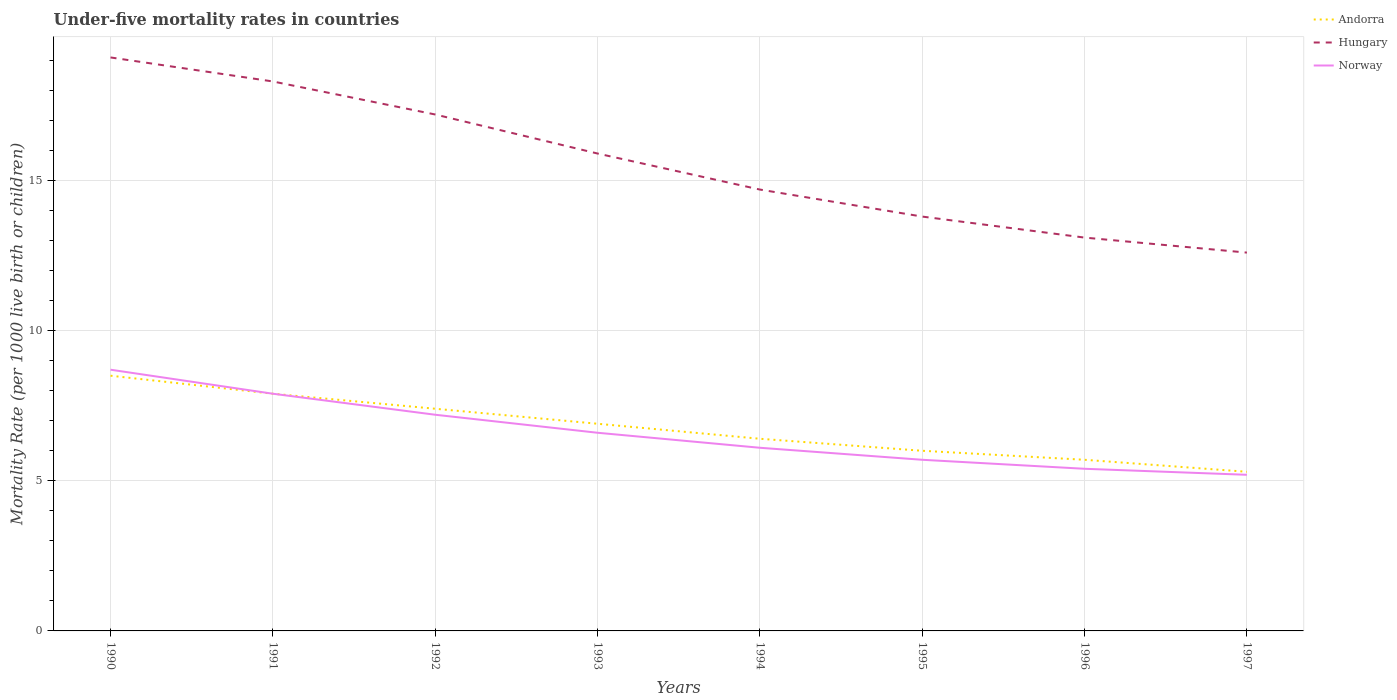Across all years, what is the maximum under-five mortality rate in Hungary?
Provide a succinct answer. 12.6. In which year was the under-five mortality rate in Norway maximum?
Keep it short and to the point. 1997. What is the total under-five mortality rate in Andorra in the graph?
Make the answer very short. 0.4. What is the difference between the highest and the second highest under-five mortality rate in Hungary?
Your answer should be compact. 6.5. How many lines are there?
Give a very brief answer. 3. How many years are there in the graph?
Give a very brief answer. 8. What is the difference between two consecutive major ticks on the Y-axis?
Keep it short and to the point. 5. Are the values on the major ticks of Y-axis written in scientific E-notation?
Your answer should be very brief. No. How many legend labels are there?
Provide a short and direct response. 3. How are the legend labels stacked?
Provide a short and direct response. Vertical. What is the title of the graph?
Ensure brevity in your answer.  Under-five mortality rates in countries. What is the label or title of the X-axis?
Provide a succinct answer. Years. What is the label or title of the Y-axis?
Your response must be concise. Mortality Rate (per 1000 live birth or children). What is the Mortality Rate (per 1000 live birth or children) in Norway in 1992?
Ensure brevity in your answer.  7.2. What is the Mortality Rate (per 1000 live birth or children) in Hungary in 1994?
Keep it short and to the point. 14.7. What is the Mortality Rate (per 1000 live birth or children) of Norway in 1994?
Keep it short and to the point. 6.1. What is the Mortality Rate (per 1000 live birth or children) in Hungary in 1995?
Make the answer very short. 13.8. What is the Mortality Rate (per 1000 live birth or children) in Norway in 1995?
Give a very brief answer. 5.7. What is the Mortality Rate (per 1000 live birth or children) in Andorra in 1996?
Your response must be concise. 5.7. What is the Mortality Rate (per 1000 live birth or children) of Hungary in 1996?
Keep it short and to the point. 13.1. Across all years, what is the minimum Mortality Rate (per 1000 live birth or children) of Andorra?
Provide a succinct answer. 5.3. Across all years, what is the minimum Mortality Rate (per 1000 live birth or children) of Hungary?
Keep it short and to the point. 12.6. Across all years, what is the minimum Mortality Rate (per 1000 live birth or children) of Norway?
Your answer should be very brief. 5.2. What is the total Mortality Rate (per 1000 live birth or children) of Andorra in the graph?
Your answer should be very brief. 54.1. What is the total Mortality Rate (per 1000 live birth or children) of Hungary in the graph?
Give a very brief answer. 124.7. What is the total Mortality Rate (per 1000 live birth or children) of Norway in the graph?
Offer a terse response. 52.8. What is the difference between the Mortality Rate (per 1000 live birth or children) in Andorra in 1990 and that in 1991?
Make the answer very short. 0.6. What is the difference between the Mortality Rate (per 1000 live birth or children) of Andorra in 1990 and that in 1992?
Ensure brevity in your answer.  1.1. What is the difference between the Mortality Rate (per 1000 live birth or children) of Hungary in 1990 and that in 1992?
Your answer should be very brief. 1.9. What is the difference between the Mortality Rate (per 1000 live birth or children) of Andorra in 1990 and that in 1993?
Make the answer very short. 1.6. What is the difference between the Mortality Rate (per 1000 live birth or children) in Hungary in 1990 and that in 1993?
Your answer should be very brief. 3.2. What is the difference between the Mortality Rate (per 1000 live birth or children) in Hungary in 1990 and that in 1994?
Your response must be concise. 4.4. What is the difference between the Mortality Rate (per 1000 live birth or children) in Norway in 1990 and that in 1994?
Make the answer very short. 2.6. What is the difference between the Mortality Rate (per 1000 live birth or children) in Hungary in 1990 and that in 1995?
Keep it short and to the point. 5.3. What is the difference between the Mortality Rate (per 1000 live birth or children) in Norway in 1990 and that in 1995?
Provide a succinct answer. 3. What is the difference between the Mortality Rate (per 1000 live birth or children) in Hungary in 1990 and that in 1996?
Keep it short and to the point. 6. What is the difference between the Mortality Rate (per 1000 live birth or children) in Norway in 1990 and that in 1996?
Offer a very short reply. 3.3. What is the difference between the Mortality Rate (per 1000 live birth or children) in Andorra in 1990 and that in 1997?
Provide a succinct answer. 3.2. What is the difference between the Mortality Rate (per 1000 live birth or children) of Norway in 1990 and that in 1997?
Provide a succinct answer. 3.5. What is the difference between the Mortality Rate (per 1000 live birth or children) of Andorra in 1991 and that in 1992?
Your answer should be very brief. 0.5. What is the difference between the Mortality Rate (per 1000 live birth or children) in Hungary in 1991 and that in 1992?
Provide a short and direct response. 1.1. What is the difference between the Mortality Rate (per 1000 live birth or children) of Andorra in 1991 and that in 1993?
Give a very brief answer. 1. What is the difference between the Mortality Rate (per 1000 live birth or children) of Andorra in 1991 and that in 1994?
Your answer should be very brief. 1.5. What is the difference between the Mortality Rate (per 1000 live birth or children) of Andorra in 1991 and that in 1997?
Provide a short and direct response. 2.6. What is the difference between the Mortality Rate (per 1000 live birth or children) of Hungary in 1991 and that in 1997?
Your response must be concise. 5.7. What is the difference between the Mortality Rate (per 1000 live birth or children) of Norway in 1991 and that in 1997?
Make the answer very short. 2.7. What is the difference between the Mortality Rate (per 1000 live birth or children) in Andorra in 1992 and that in 1993?
Offer a terse response. 0.5. What is the difference between the Mortality Rate (per 1000 live birth or children) in Hungary in 1992 and that in 1993?
Your answer should be compact. 1.3. What is the difference between the Mortality Rate (per 1000 live birth or children) in Norway in 1992 and that in 1993?
Provide a short and direct response. 0.6. What is the difference between the Mortality Rate (per 1000 live birth or children) in Hungary in 1992 and that in 1995?
Your answer should be very brief. 3.4. What is the difference between the Mortality Rate (per 1000 live birth or children) in Norway in 1992 and that in 1996?
Make the answer very short. 1.8. What is the difference between the Mortality Rate (per 1000 live birth or children) of Hungary in 1992 and that in 1997?
Provide a succinct answer. 4.6. What is the difference between the Mortality Rate (per 1000 live birth or children) in Norway in 1993 and that in 1994?
Give a very brief answer. 0.5. What is the difference between the Mortality Rate (per 1000 live birth or children) of Andorra in 1993 and that in 1995?
Give a very brief answer. 0.9. What is the difference between the Mortality Rate (per 1000 live birth or children) of Norway in 1993 and that in 1995?
Provide a short and direct response. 0.9. What is the difference between the Mortality Rate (per 1000 live birth or children) in Andorra in 1993 and that in 1996?
Offer a very short reply. 1.2. What is the difference between the Mortality Rate (per 1000 live birth or children) of Norway in 1993 and that in 1996?
Your answer should be very brief. 1.2. What is the difference between the Mortality Rate (per 1000 live birth or children) of Andorra in 1994 and that in 1995?
Offer a terse response. 0.4. What is the difference between the Mortality Rate (per 1000 live birth or children) in Hungary in 1994 and that in 1995?
Offer a terse response. 0.9. What is the difference between the Mortality Rate (per 1000 live birth or children) in Norway in 1994 and that in 1995?
Your answer should be very brief. 0.4. What is the difference between the Mortality Rate (per 1000 live birth or children) in Andorra in 1994 and that in 1996?
Offer a terse response. 0.7. What is the difference between the Mortality Rate (per 1000 live birth or children) in Hungary in 1994 and that in 1996?
Offer a very short reply. 1.6. What is the difference between the Mortality Rate (per 1000 live birth or children) of Norway in 1994 and that in 1996?
Give a very brief answer. 0.7. What is the difference between the Mortality Rate (per 1000 live birth or children) in Andorra in 1994 and that in 1997?
Ensure brevity in your answer.  1.1. What is the difference between the Mortality Rate (per 1000 live birth or children) in Hungary in 1994 and that in 1997?
Offer a terse response. 2.1. What is the difference between the Mortality Rate (per 1000 live birth or children) of Norway in 1994 and that in 1997?
Your answer should be compact. 0.9. What is the difference between the Mortality Rate (per 1000 live birth or children) in Andorra in 1995 and that in 1996?
Offer a terse response. 0.3. What is the difference between the Mortality Rate (per 1000 live birth or children) in Hungary in 1995 and that in 1996?
Make the answer very short. 0.7. What is the difference between the Mortality Rate (per 1000 live birth or children) of Norway in 1995 and that in 1996?
Offer a terse response. 0.3. What is the difference between the Mortality Rate (per 1000 live birth or children) in Andorra in 1995 and that in 1997?
Ensure brevity in your answer.  0.7. What is the difference between the Mortality Rate (per 1000 live birth or children) of Hungary in 1995 and that in 1997?
Your response must be concise. 1.2. What is the difference between the Mortality Rate (per 1000 live birth or children) in Hungary in 1996 and that in 1997?
Your answer should be compact. 0.5. What is the difference between the Mortality Rate (per 1000 live birth or children) in Andorra in 1990 and the Mortality Rate (per 1000 live birth or children) in Hungary in 1991?
Your answer should be very brief. -9.8. What is the difference between the Mortality Rate (per 1000 live birth or children) of Andorra in 1990 and the Mortality Rate (per 1000 live birth or children) of Norway in 1991?
Offer a very short reply. 0.6. What is the difference between the Mortality Rate (per 1000 live birth or children) in Hungary in 1990 and the Mortality Rate (per 1000 live birth or children) in Norway in 1991?
Your answer should be very brief. 11.2. What is the difference between the Mortality Rate (per 1000 live birth or children) of Andorra in 1990 and the Mortality Rate (per 1000 live birth or children) of Hungary in 1992?
Keep it short and to the point. -8.7. What is the difference between the Mortality Rate (per 1000 live birth or children) of Andorra in 1990 and the Mortality Rate (per 1000 live birth or children) of Norway in 1992?
Provide a short and direct response. 1.3. What is the difference between the Mortality Rate (per 1000 live birth or children) of Hungary in 1990 and the Mortality Rate (per 1000 live birth or children) of Norway in 1992?
Offer a terse response. 11.9. What is the difference between the Mortality Rate (per 1000 live birth or children) of Hungary in 1990 and the Mortality Rate (per 1000 live birth or children) of Norway in 1993?
Give a very brief answer. 12.5. What is the difference between the Mortality Rate (per 1000 live birth or children) in Andorra in 1990 and the Mortality Rate (per 1000 live birth or children) in Hungary in 1994?
Provide a succinct answer. -6.2. What is the difference between the Mortality Rate (per 1000 live birth or children) of Andorra in 1990 and the Mortality Rate (per 1000 live birth or children) of Norway in 1994?
Provide a short and direct response. 2.4. What is the difference between the Mortality Rate (per 1000 live birth or children) in Hungary in 1990 and the Mortality Rate (per 1000 live birth or children) in Norway in 1994?
Offer a terse response. 13. What is the difference between the Mortality Rate (per 1000 live birth or children) in Andorra in 1990 and the Mortality Rate (per 1000 live birth or children) in Norway in 1995?
Make the answer very short. 2.8. What is the difference between the Mortality Rate (per 1000 live birth or children) of Andorra in 1990 and the Mortality Rate (per 1000 live birth or children) of Hungary in 1996?
Provide a succinct answer. -4.6. What is the difference between the Mortality Rate (per 1000 live birth or children) in Andorra in 1990 and the Mortality Rate (per 1000 live birth or children) in Hungary in 1997?
Your response must be concise. -4.1. What is the difference between the Mortality Rate (per 1000 live birth or children) in Hungary in 1990 and the Mortality Rate (per 1000 live birth or children) in Norway in 1997?
Provide a succinct answer. 13.9. What is the difference between the Mortality Rate (per 1000 live birth or children) of Andorra in 1991 and the Mortality Rate (per 1000 live birth or children) of Hungary in 1992?
Your answer should be very brief. -9.3. What is the difference between the Mortality Rate (per 1000 live birth or children) in Hungary in 1991 and the Mortality Rate (per 1000 live birth or children) in Norway in 1992?
Offer a very short reply. 11.1. What is the difference between the Mortality Rate (per 1000 live birth or children) in Andorra in 1991 and the Mortality Rate (per 1000 live birth or children) in Hungary in 1993?
Make the answer very short. -8. What is the difference between the Mortality Rate (per 1000 live birth or children) of Andorra in 1991 and the Mortality Rate (per 1000 live birth or children) of Hungary in 1994?
Your answer should be compact. -6.8. What is the difference between the Mortality Rate (per 1000 live birth or children) in Andorra in 1991 and the Mortality Rate (per 1000 live birth or children) in Norway in 1994?
Your answer should be very brief. 1.8. What is the difference between the Mortality Rate (per 1000 live birth or children) of Andorra in 1991 and the Mortality Rate (per 1000 live birth or children) of Norway in 1995?
Offer a very short reply. 2.2. What is the difference between the Mortality Rate (per 1000 live birth or children) of Andorra in 1991 and the Mortality Rate (per 1000 live birth or children) of Hungary in 1997?
Make the answer very short. -4.7. What is the difference between the Mortality Rate (per 1000 live birth or children) of Andorra in 1991 and the Mortality Rate (per 1000 live birth or children) of Norway in 1997?
Provide a short and direct response. 2.7. What is the difference between the Mortality Rate (per 1000 live birth or children) in Hungary in 1991 and the Mortality Rate (per 1000 live birth or children) in Norway in 1997?
Offer a very short reply. 13.1. What is the difference between the Mortality Rate (per 1000 live birth or children) of Andorra in 1992 and the Mortality Rate (per 1000 live birth or children) of Hungary in 1993?
Your answer should be compact. -8.5. What is the difference between the Mortality Rate (per 1000 live birth or children) in Andorra in 1992 and the Mortality Rate (per 1000 live birth or children) in Norway in 1993?
Your answer should be compact. 0.8. What is the difference between the Mortality Rate (per 1000 live birth or children) of Andorra in 1992 and the Mortality Rate (per 1000 live birth or children) of Hungary in 1994?
Offer a very short reply. -7.3. What is the difference between the Mortality Rate (per 1000 live birth or children) of Hungary in 1992 and the Mortality Rate (per 1000 live birth or children) of Norway in 1994?
Your answer should be very brief. 11.1. What is the difference between the Mortality Rate (per 1000 live birth or children) in Andorra in 1992 and the Mortality Rate (per 1000 live birth or children) in Hungary in 1995?
Keep it short and to the point. -6.4. What is the difference between the Mortality Rate (per 1000 live birth or children) of Andorra in 1992 and the Mortality Rate (per 1000 live birth or children) of Norway in 1995?
Offer a terse response. 1.7. What is the difference between the Mortality Rate (per 1000 live birth or children) of Hungary in 1992 and the Mortality Rate (per 1000 live birth or children) of Norway in 1995?
Provide a succinct answer. 11.5. What is the difference between the Mortality Rate (per 1000 live birth or children) in Andorra in 1992 and the Mortality Rate (per 1000 live birth or children) in Hungary in 1996?
Provide a succinct answer. -5.7. What is the difference between the Mortality Rate (per 1000 live birth or children) of Andorra in 1992 and the Mortality Rate (per 1000 live birth or children) of Norway in 1996?
Keep it short and to the point. 2. What is the difference between the Mortality Rate (per 1000 live birth or children) of Andorra in 1992 and the Mortality Rate (per 1000 live birth or children) of Hungary in 1997?
Offer a very short reply. -5.2. What is the difference between the Mortality Rate (per 1000 live birth or children) in Andorra in 1992 and the Mortality Rate (per 1000 live birth or children) in Norway in 1997?
Your answer should be compact. 2.2. What is the difference between the Mortality Rate (per 1000 live birth or children) in Hungary in 1992 and the Mortality Rate (per 1000 live birth or children) in Norway in 1997?
Make the answer very short. 12. What is the difference between the Mortality Rate (per 1000 live birth or children) of Andorra in 1993 and the Mortality Rate (per 1000 live birth or children) of Hungary in 1994?
Ensure brevity in your answer.  -7.8. What is the difference between the Mortality Rate (per 1000 live birth or children) in Andorra in 1993 and the Mortality Rate (per 1000 live birth or children) in Norway in 1994?
Keep it short and to the point. 0.8. What is the difference between the Mortality Rate (per 1000 live birth or children) in Andorra in 1993 and the Mortality Rate (per 1000 live birth or children) in Hungary in 1995?
Keep it short and to the point. -6.9. What is the difference between the Mortality Rate (per 1000 live birth or children) of Hungary in 1993 and the Mortality Rate (per 1000 live birth or children) of Norway in 1995?
Your response must be concise. 10.2. What is the difference between the Mortality Rate (per 1000 live birth or children) of Andorra in 1993 and the Mortality Rate (per 1000 live birth or children) of Hungary in 1996?
Ensure brevity in your answer.  -6.2. What is the difference between the Mortality Rate (per 1000 live birth or children) in Andorra in 1993 and the Mortality Rate (per 1000 live birth or children) in Norway in 1996?
Ensure brevity in your answer.  1.5. What is the difference between the Mortality Rate (per 1000 live birth or children) of Andorra in 1993 and the Mortality Rate (per 1000 live birth or children) of Hungary in 1997?
Offer a very short reply. -5.7. What is the difference between the Mortality Rate (per 1000 live birth or children) of Andorra in 1993 and the Mortality Rate (per 1000 live birth or children) of Norway in 1997?
Ensure brevity in your answer.  1.7. What is the difference between the Mortality Rate (per 1000 live birth or children) in Hungary in 1993 and the Mortality Rate (per 1000 live birth or children) in Norway in 1997?
Offer a very short reply. 10.7. What is the difference between the Mortality Rate (per 1000 live birth or children) of Andorra in 1994 and the Mortality Rate (per 1000 live birth or children) of Norway in 1995?
Provide a succinct answer. 0.7. What is the difference between the Mortality Rate (per 1000 live birth or children) of Hungary in 1994 and the Mortality Rate (per 1000 live birth or children) of Norway in 1995?
Your answer should be very brief. 9. What is the difference between the Mortality Rate (per 1000 live birth or children) in Andorra in 1994 and the Mortality Rate (per 1000 live birth or children) in Norway in 1996?
Your response must be concise. 1. What is the difference between the Mortality Rate (per 1000 live birth or children) of Hungary in 1994 and the Mortality Rate (per 1000 live birth or children) of Norway in 1996?
Provide a succinct answer. 9.3. What is the difference between the Mortality Rate (per 1000 live birth or children) in Andorra in 1994 and the Mortality Rate (per 1000 live birth or children) in Norway in 1997?
Give a very brief answer. 1.2. What is the difference between the Mortality Rate (per 1000 live birth or children) of Andorra in 1995 and the Mortality Rate (per 1000 live birth or children) of Norway in 1997?
Offer a very short reply. 0.8. What is the difference between the Mortality Rate (per 1000 live birth or children) of Hungary in 1995 and the Mortality Rate (per 1000 live birth or children) of Norway in 1997?
Offer a terse response. 8.6. What is the difference between the Mortality Rate (per 1000 live birth or children) in Andorra in 1996 and the Mortality Rate (per 1000 live birth or children) in Hungary in 1997?
Your answer should be compact. -6.9. What is the difference between the Mortality Rate (per 1000 live birth or children) in Andorra in 1996 and the Mortality Rate (per 1000 live birth or children) in Norway in 1997?
Keep it short and to the point. 0.5. What is the average Mortality Rate (per 1000 live birth or children) of Andorra per year?
Make the answer very short. 6.76. What is the average Mortality Rate (per 1000 live birth or children) of Hungary per year?
Your answer should be very brief. 15.59. What is the average Mortality Rate (per 1000 live birth or children) of Norway per year?
Your response must be concise. 6.6. In the year 1990, what is the difference between the Mortality Rate (per 1000 live birth or children) of Andorra and Mortality Rate (per 1000 live birth or children) of Norway?
Offer a very short reply. -0.2. In the year 1990, what is the difference between the Mortality Rate (per 1000 live birth or children) in Hungary and Mortality Rate (per 1000 live birth or children) in Norway?
Provide a short and direct response. 10.4. In the year 1991, what is the difference between the Mortality Rate (per 1000 live birth or children) of Andorra and Mortality Rate (per 1000 live birth or children) of Norway?
Ensure brevity in your answer.  0. In the year 1992, what is the difference between the Mortality Rate (per 1000 live birth or children) in Andorra and Mortality Rate (per 1000 live birth or children) in Norway?
Ensure brevity in your answer.  0.2. In the year 1993, what is the difference between the Mortality Rate (per 1000 live birth or children) in Andorra and Mortality Rate (per 1000 live birth or children) in Hungary?
Ensure brevity in your answer.  -9. In the year 1993, what is the difference between the Mortality Rate (per 1000 live birth or children) of Andorra and Mortality Rate (per 1000 live birth or children) of Norway?
Your answer should be compact. 0.3. In the year 1994, what is the difference between the Mortality Rate (per 1000 live birth or children) in Andorra and Mortality Rate (per 1000 live birth or children) in Hungary?
Offer a very short reply. -8.3. In the year 1994, what is the difference between the Mortality Rate (per 1000 live birth or children) in Andorra and Mortality Rate (per 1000 live birth or children) in Norway?
Provide a short and direct response. 0.3. In the year 1994, what is the difference between the Mortality Rate (per 1000 live birth or children) in Hungary and Mortality Rate (per 1000 live birth or children) in Norway?
Make the answer very short. 8.6. In the year 1995, what is the difference between the Mortality Rate (per 1000 live birth or children) of Andorra and Mortality Rate (per 1000 live birth or children) of Hungary?
Your answer should be very brief. -7.8. In the year 1996, what is the difference between the Mortality Rate (per 1000 live birth or children) of Hungary and Mortality Rate (per 1000 live birth or children) of Norway?
Offer a very short reply. 7.7. What is the ratio of the Mortality Rate (per 1000 live birth or children) in Andorra in 1990 to that in 1991?
Ensure brevity in your answer.  1.08. What is the ratio of the Mortality Rate (per 1000 live birth or children) of Hungary in 1990 to that in 1991?
Provide a succinct answer. 1.04. What is the ratio of the Mortality Rate (per 1000 live birth or children) in Norway in 1990 to that in 1991?
Your response must be concise. 1.1. What is the ratio of the Mortality Rate (per 1000 live birth or children) of Andorra in 1990 to that in 1992?
Provide a short and direct response. 1.15. What is the ratio of the Mortality Rate (per 1000 live birth or children) of Hungary in 1990 to that in 1992?
Offer a terse response. 1.11. What is the ratio of the Mortality Rate (per 1000 live birth or children) of Norway in 1990 to that in 1992?
Give a very brief answer. 1.21. What is the ratio of the Mortality Rate (per 1000 live birth or children) in Andorra in 1990 to that in 1993?
Your answer should be very brief. 1.23. What is the ratio of the Mortality Rate (per 1000 live birth or children) of Hungary in 1990 to that in 1993?
Give a very brief answer. 1.2. What is the ratio of the Mortality Rate (per 1000 live birth or children) of Norway in 1990 to that in 1993?
Your response must be concise. 1.32. What is the ratio of the Mortality Rate (per 1000 live birth or children) in Andorra in 1990 to that in 1994?
Offer a very short reply. 1.33. What is the ratio of the Mortality Rate (per 1000 live birth or children) in Hungary in 1990 to that in 1994?
Provide a succinct answer. 1.3. What is the ratio of the Mortality Rate (per 1000 live birth or children) of Norway in 1990 to that in 1994?
Your answer should be compact. 1.43. What is the ratio of the Mortality Rate (per 1000 live birth or children) of Andorra in 1990 to that in 1995?
Your answer should be very brief. 1.42. What is the ratio of the Mortality Rate (per 1000 live birth or children) of Hungary in 1990 to that in 1995?
Give a very brief answer. 1.38. What is the ratio of the Mortality Rate (per 1000 live birth or children) in Norway in 1990 to that in 1995?
Give a very brief answer. 1.53. What is the ratio of the Mortality Rate (per 1000 live birth or children) in Andorra in 1990 to that in 1996?
Ensure brevity in your answer.  1.49. What is the ratio of the Mortality Rate (per 1000 live birth or children) of Hungary in 1990 to that in 1996?
Provide a short and direct response. 1.46. What is the ratio of the Mortality Rate (per 1000 live birth or children) in Norway in 1990 to that in 1996?
Provide a succinct answer. 1.61. What is the ratio of the Mortality Rate (per 1000 live birth or children) in Andorra in 1990 to that in 1997?
Provide a succinct answer. 1.6. What is the ratio of the Mortality Rate (per 1000 live birth or children) of Hungary in 1990 to that in 1997?
Your response must be concise. 1.52. What is the ratio of the Mortality Rate (per 1000 live birth or children) in Norway in 1990 to that in 1997?
Provide a short and direct response. 1.67. What is the ratio of the Mortality Rate (per 1000 live birth or children) of Andorra in 1991 to that in 1992?
Offer a terse response. 1.07. What is the ratio of the Mortality Rate (per 1000 live birth or children) of Hungary in 1991 to that in 1992?
Keep it short and to the point. 1.06. What is the ratio of the Mortality Rate (per 1000 live birth or children) of Norway in 1991 to that in 1992?
Keep it short and to the point. 1.1. What is the ratio of the Mortality Rate (per 1000 live birth or children) in Andorra in 1991 to that in 1993?
Give a very brief answer. 1.14. What is the ratio of the Mortality Rate (per 1000 live birth or children) of Hungary in 1991 to that in 1993?
Ensure brevity in your answer.  1.15. What is the ratio of the Mortality Rate (per 1000 live birth or children) in Norway in 1991 to that in 1993?
Ensure brevity in your answer.  1.2. What is the ratio of the Mortality Rate (per 1000 live birth or children) in Andorra in 1991 to that in 1994?
Offer a very short reply. 1.23. What is the ratio of the Mortality Rate (per 1000 live birth or children) of Hungary in 1991 to that in 1994?
Your response must be concise. 1.24. What is the ratio of the Mortality Rate (per 1000 live birth or children) of Norway in 1991 to that in 1994?
Offer a terse response. 1.3. What is the ratio of the Mortality Rate (per 1000 live birth or children) of Andorra in 1991 to that in 1995?
Keep it short and to the point. 1.32. What is the ratio of the Mortality Rate (per 1000 live birth or children) of Hungary in 1991 to that in 1995?
Ensure brevity in your answer.  1.33. What is the ratio of the Mortality Rate (per 1000 live birth or children) in Norway in 1991 to that in 1995?
Ensure brevity in your answer.  1.39. What is the ratio of the Mortality Rate (per 1000 live birth or children) of Andorra in 1991 to that in 1996?
Your answer should be very brief. 1.39. What is the ratio of the Mortality Rate (per 1000 live birth or children) in Hungary in 1991 to that in 1996?
Provide a succinct answer. 1.4. What is the ratio of the Mortality Rate (per 1000 live birth or children) in Norway in 1991 to that in 1996?
Keep it short and to the point. 1.46. What is the ratio of the Mortality Rate (per 1000 live birth or children) in Andorra in 1991 to that in 1997?
Keep it short and to the point. 1.49. What is the ratio of the Mortality Rate (per 1000 live birth or children) in Hungary in 1991 to that in 1997?
Offer a terse response. 1.45. What is the ratio of the Mortality Rate (per 1000 live birth or children) of Norway in 1991 to that in 1997?
Keep it short and to the point. 1.52. What is the ratio of the Mortality Rate (per 1000 live birth or children) of Andorra in 1992 to that in 1993?
Offer a terse response. 1.07. What is the ratio of the Mortality Rate (per 1000 live birth or children) of Hungary in 1992 to that in 1993?
Give a very brief answer. 1.08. What is the ratio of the Mortality Rate (per 1000 live birth or children) of Norway in 1992 to that in 1993?
Offer a very short reply. 1.09. What is the ratio of the Mortality Rate (per 1000 live birth or children) of Andorra in 1992 to that in 1994?
Your answer should be very brief. 1.16. What is the ratio of the Mortality Rate (per 1000 live birth or children) in Hungary in 1992 to that in 1994?
Make the answer very short. 1.17. What is the ratio of the Mortality Rate (per 1000 live birth or children) in Norway in 1992 to that in 1994?
Offer a very short reply. 1.18. What is the ratio of the Mortality Rate (per 1000 live birth or children) of Andorra in 1992 to that in 1995?
Provide a short and direct response. 1.23. What is the ratio of the Mortality Rate (per 1000 live birth or children) in Hungary in 1992 to that in 1995?
Provide a succinct answer. 1.25. What is the ratio of the Mortality Rate (per 1000 live birth or children) in Norway in 1992 to that in 1995?
Provide a succinct answer. 1.26. What is the ratio of the Mortality Rate (per 1000 live birth or children) in Andorra in 1992 to that in 1996?
Provide a short and direct response. 1.3. What is the ratio of the Mortality Rate (per 1000 live birth or children) of Hungary in 1992 to that in 1996?
Provide a succinct answer. 1.31. What is the ratio of the Mortality Rate (per 1000 live birth or children) in Andorra in 1992 to that in 1997?
Provide a succinct answer. 1.4. What is the ratio of the Mortality Rate (per 1000 live birth or children) in Hungary in 1992 to that in 1997?
Ensure brevity in your answer.  1.37. What is the ratio of the Mortality Rate (per 1000 live birth or children) in Norway in 1992 to that in 1997?
Your answer should be compact. 1.38. What is the ratio of the Mortality Rate (per 1000 live birth or children) in Andorra in 1993 to that in 1994?
Your answer should be very brief. 1.08. What is the ratio of the Mortality Rate (per 1000 live birth or children) of Hungary in 1993 to that in 1994?
Your answer should be very brief. 1.08. What is the ratio of the Mortality Rate (per 1000 live birth or children) of Norway in 1993 to that in 1994?
Your answer should be very brief. 1.08. What is the ratio of the Mortality Rate (per 1000 live birth or children) of Andorra in 1993 to that in 1995?
Keep it short and to the point. 1.15. What is the ratio of the Mortality Rate (per 1000 live birth or children) of Hungary in 1993 to that in 1995?
Give a very brief answer. 1.15. What is the ratio of the Mortality Rate (per 1000 live birth or children) of Norway in 1993 to that in 1995?
Ensure brevity in your answer.  1.16. What is the ratio of the Mortality Rate (per 1000 live birth or children) of Andorra in 1993 to that in 1996?
Your answer should be compact. 1.21. What is the ratio of the Mortality Rate (per 1000 live birth or children) of Hungary in 1993 to that in 1996?
Your answer should be very brief. 1.21. What is the ratio of the Mortality Rate (per 1000 live birth or children) of Norway in 1993 to that in 1996?
Make the answer very short. 1.22. What is the ratio of the Mortality Rate (per 1000 live birth or children) in Andorra in 1993 to that in 1997?
Offer a terse response. 1.3. What is the ratio of the Mortality Rate (per 1000 live birth or children) of Hungary in 1993 to that in 1997?
Your answer should be very brief. 1.26. What is the ratio of the Mortality Rate (per 1000 live birth or children) in Norway in 1993 to that in 1997?
Offer a terse response. 1.27. What is the ratio of the Mortality Rate (per 1000 live birth or children) in Andorra in 1994 to that in 1995?
Offer a terse response. 1.07. What is the ratio of the Mortality Rate (per 1000 live birth or children) of Hungary in 1994 to that in 1995?
Offer a very short reply. 1.07. What is the ratio of the Mortality Rate (per 1000 live birth or children) in Norway in 1994 to that in 1995?
Your response must be concise. 1.07. What is the ratio of the Mortality Rate (per 1000 live birth or children) in Andorra in 1994 to that in 1996?
Your response must be concise. 1.12. What is the ratio of the Mortality Rate (per 1000 live birth or children) in Hungary in 1994 to that in 1996?
Your response must be concise. 1.12. What is the ratio of the Mortality Rate (per 1000 live birth or children) of Norway in 1994 to that in 1996?
Ensure brevity in your answer.  1.13. What is the ratio of the Mortality Rate (per 1000 live birth or children) of Andorra in 1994 to that in 1997?
Provide a succinct answer. 1.21. What is the ratio of the Mortality Rate (per 1000 live birth or children) in Norway in 1994 to that in 1997?
Give a very brief answer. 1.17. What is the ratio of the Mortality Rate (per 1000 live birth or children) of Andorra in 1995 to that in 1996?
Provide a succinct answer. 1.05. What is the ratio of the Mortality Rate (per 1000 live birth or children) of Hungary in 1995 to that in 1996?
Offer a very short reply. 1.05. What is the ratio of the Mortality Rate (per 1000 live birth or children) of Norway in 1995 to that in 1996?
Provide a succinct answer. 1.06. What is the ratio of the Mortality Rate (per 1000 live birth or children) of Andorra in 1995 to that in 1997?
Your answer should be compact. 1.13. What is the ratio of the Mortality Rate (per 1000 live birth or children) of Hungary in 1995 to that in 1997?
Provide a short and direct response. 1.1. What is the ratio of the Mortality Rate (per 1000 live birth or children) in Norway in 1995 to that in 1997?
Ensure brevity in your answer.  1.1. What is the ratio of the Mortality Rate (per 1000 live birth or children) of Andorra in 1996 to that in 1997?
Provide a succinct answer. 1.08. What is the ratio of the Mortality Rate (per 1000 live birth or children) of Hungary in 1996 to that in 1997?
Provide a short and direct response. 1.04. What is the ratio of the Mortality Rate (per 1000 live birth or children) of Norway in 1996 to that in 1997?
Ensure brevity in your answer.  1.04. What is the difference between the highest and the second highest Mortality Rate (per 1000 live birth or children) in Norway?
Your answer should be very brief. 0.8. What is the difference between the highest and the lowest Mortality Rate (per 1000 live birth or children) of Hungary?
Your answer should be compact. 6.5. What is the difference between the highest and the lowest Mortality Rate (per 1000 live birth or children) of Norway?
Your answer should be compact. 3.5. 